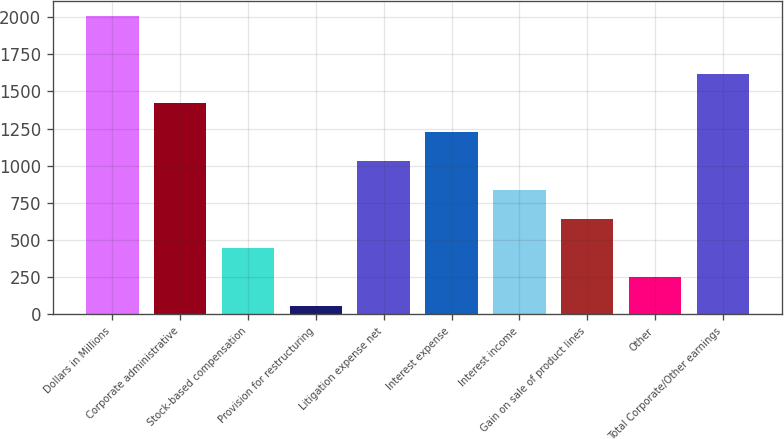Convert chart. <chart><loc_0><loc_0><loc_500><loc_500><bar_chart><fcel>Dollars in Millions<fcel>Corporate administrative<fcel>Stock-based compensation<fcel>Provision for restructuring<fcel>Litigation expense net<fcel>Interest expense<fcel>Interest income<fcel>Gain on sale of product lines<fcel>Other<fcel>Total Corporate/Other earnings<nl><fcel>2006<fcel>1421.9<fcel>448.4<fcel>59<fcel>1032.5<fcel>1227.2<fcel>837.8<fcel>643.1<fcel>253.7<fcel>1616.6<nl></chart> 